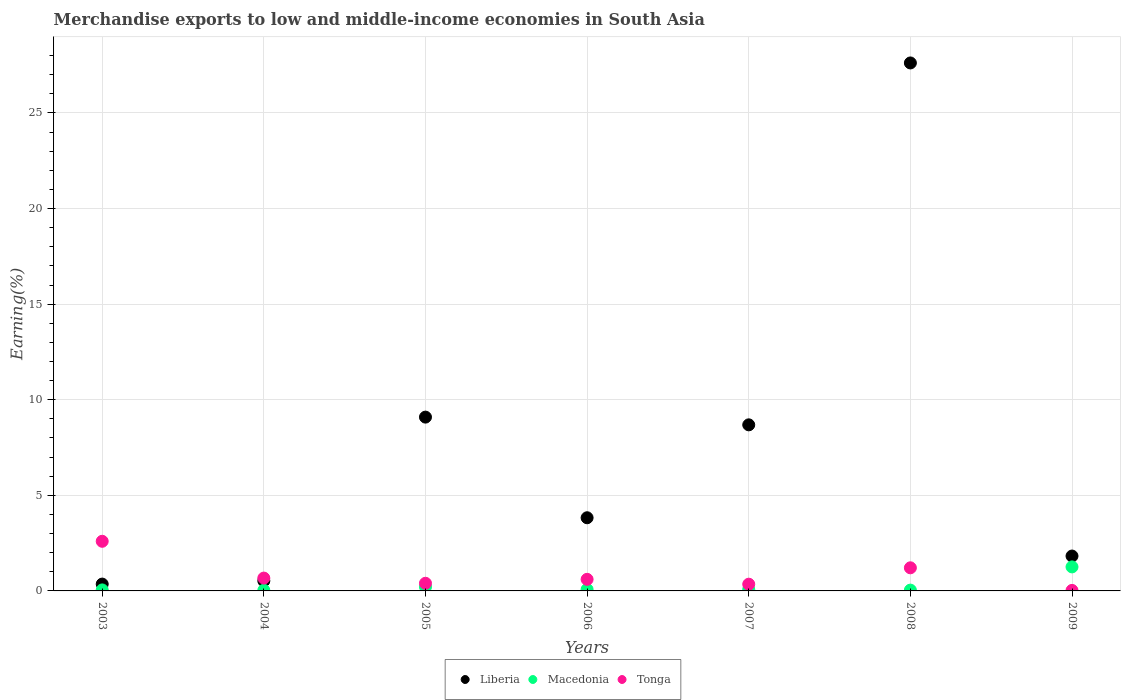What is the percentage of amount earned from merchandise exports in Liberia in 2009?
Your answer should be very brief. 1.82. Across all years, what is the maximum percentage of amount earned from merchandise exports in Liberia?
Make the answer very short. 27.61. Across all years, what is the minimum percentage of amount earned from merchandise exports in Liberia?
Give a very brief answer. 0.36. In which year was the percentage of amount earned from merchandise exports in Macedonia maximum?
Offer a very short reply. 2009. In which year was the percentage of amount earned from merchandise exports in Tonga minimum?
Give a very brief answer. 2009. What is the total percentage of amount earned from merchandise exports in Tonga in the graph?
Your response must be concise. 5.86. What is the difference between the percentage of amount earned from merchandise exports in Liberia in 2003 and that in 2007?
Offer a terse response. -8.33. What is the difference between the percentage of amount earned from merchandise exports in Tonga in 2003 and the percentage of amount earned from merchandise exports in Liberia in 2008?
Offer a terse response. -25.02. What is the average percentage of amount earned from merchandise exports in Liberia per year?
Keep it short and to the point. 7.42. In the year 2004, what is the difference between the percentage of amount earned from merchandise exports in Macedonia and percentage of amount earned from merchandise exports in Tonga?
Give a very brief answer. -0.64. In how many years, is the percentage of amount earned from merchandise exports in Liberia greater than 6 %?
Your response must be concise. 3. What is the ratio of the percentage of amount earned from merchandise exports in Tonga in 2006 to that in 2007?
Your answer should be compact. 1.72. What is the difference between the highest and the second highest percentage of amount earned from merchandise exports in Liberia?
Your answer should be compact. 18.52. What is the difference between the highest and the lowest percentage of amount earned from merchandise exports in Macedonia?
Make the answer very short. 1.22. In how many years, is the percentage of amount earned from merchandise exports in Tonga greater than the average percentage of amount earned from merchandise exports in Tonga taken over all years?
Give a very brief answer. 2. Is it the case that in every year, the sum of the percentage of amount earned from merchandise exports in Tonga and percentage of amount earned from merchandise exports in Macedonia  is greater than the percentage of amount earned from merchandise exports in Liberia?
Provide a short and direct response. No. Does the percentage of amount earned from merchandise exports in Liberia monotonically increase over the years?
Provide a succinct answer. No. Is the percentage of amount earned from merchandise exports in Tonga strictly greater than the percentage of amount earned from merchandise exports in Liberia over the years?
Make the answer very short. No. Is the percentage of amount earned from merchandise exports in Macedonia strictly less than the percentage of amount earned from merchandise exports in Tonga over the years?
Provide a short and direct response. No. How many years are there in the graph?
Offer a very short reply. 7. Are the values on the major ticks of Y-axis written in scientific E-notation?
Your answer should be compact. No. How many legend labels are there?
Your response must be concise. 3. What is the title of the graph?
Provide a succinct answer. Merchandise exports to low and middle-income economies in South Asia. Does "Virgin Islands" appear as one of the legend labels in the graph?
Your answer should be very brief. No. What is the label or title of the Y-axis?
Your answer should be very brief. Earning(%). What is the Earning(%) in Liberia in 2003?
Keep it short and to the point. 0.36. What is the Earning(%) in Macedonia in 2003?
Make the answer very short. 0.05. What is the Earning(%) in Tonga in 2003?
Provide a succinct answer. 2.6. What is the Earning(%) of Liberia in 2004?
Make the answer very short. 0.53. What is the Earning(%) in Macedonia in 2004?
Offer a very short reply. 0.03. What is the Earning(%) of Tonga in 2004?
Make the answer very short. 0.67. What is the Earning(%) of Liberia in 2005?
Your response must be concise. 9.09. What is the Earning(%) of Macedonia in 2005?
Provide a succinct answer. 0.21. What is the Earning(%) of Tonga in 2005?
Ensure brevity in your answer.  0.4. What is the Earning(%) in Liberia in 2006?
Your answer should be very brief. 3.83. What is the Earning(%) in Macedonia in 2006?
Your answer should be compact. 0.08. What is the Earning(%) of Tonga in 2006?
Provide a succinct answer. 0.61. What is the Earning(%) of Liberia in 2007?
Your response must be concise. 8.69. What is the Earning(%) in Macedonia in 2007?
Offer a very short reply. 0.08. What is the Earning(%) in Tonga in 2007?
Keep it short and to the point. 0.35. What is the Earning(%) of Liberia in 2008?
Offer a terse response. 27.61. What is the Earning(%) in Macedonia in 2008?
Offer a terse response. 0.04. What is the Earning(%) in Tonga in 2008?
Provide a succinct answer. 1.21. What is the Earning(%) of Liberia in 2009?
Give a very brief answer. 1.82. What is the Earning(%) in Macedonia in 2009?
Ensure brevity in your answer.  1.26. What is the Earning(%) in Tonga in 2009?
Your answer should be compact. 0.03. Across all years, what is the maximum Earning(%) in Liberia?
Ensure brevity in your answer.  27.61. Across all years, what is the maximum Earning(%) of Macedonia?
Offer a terse response. 1.26. Across all years, what is the maximum Earning(%) of Tonga?
Provide a short and direct response. 2.6. Across all years, what is the minimum Earning(%) of Liberia?
Provide a short and direct response. 0.36. Across all years, what is the minimum Earning(%) in Macedonia?
Make the answer very short. 0.03. Across all years, what is the minimum Earning(%) in Tonga?
Your answer should be very brief. 0.03. What is the total Earning(%) in Liberia in the graph?
Give a very brief answer. 51.93. What is the total Earning(%) of Macedonia in the graph?
Provide a succinct answer. 1.75. What is the total Earning(%) of Tonga in the graph?
Your answer should be very brief. 5.86. What is the difference between the Earning(%) of Liberia in 2003 and that in 2004?
Provide a short and direct response. -0.17. What is the difference between the Earning(%) of Macedonia in 2003 and that in 2004?
Provide a short and direct response. 0.02. What is the difference between the Earning(%) in Tonga in 2003 and that in 2004?
Your answer should be compact. 1.92. What is the difference between the Earning(%) of Liberia in 2003 and that in 2005?
Ensure brevity in your answer.  -8.73. What is the difference between the Earning(%) of Macedonia in 2003 and that in 2005?
Offer a terse response. -0.16. What is the difference between the Earning(%) of Tonga in 2003 and that in 2005?
Offer a very short reply. 2.2. What is the difference between the Earning(%) in Liberia in 2003 and that in 2006?
Your answer should be compact. -3.47. What is the difference between the Earning(%) in Macedonia in 2003 and that in 2006?
Provide a succinct answer. -0.02. What is the difference between the Earning(%) of Tonga in 2003 and that in 2006?
Offer a very short reply. 1.99. What is the difference between the Earning(%) in Liberia in 2003 and that in 2007?
Your answer should be compact. -8.33. What is the difference between the Earning(%) of Macedonia in 2003 and that in 2007?
Provide a short and direct response. -0.03. What is the difference between the Earning(%) of Tonga in 2003 and that in 2007?
Offer a terse response. 2.24. What is the difference between the Earning(%) of Liberia in 2003 and that in 2008?
Make the answer very short. -27.26. What is the difference between the Earning(%) of Macedonia in 2003 and that in 2008?
Make the answer very short. 0.01. What is the difference between the Earning(%) of Tonga in 2003 and that in 2008?
Provide a short and direct response. 1.39. What is the difference between the Earning(%) in Liberia in 2003 and that in 2009?
Keep it short and to the point. -1.47. What is the difference between the Earning(%) in Macedonia in 2003 and that in 2009?
Give a very brief answer. -1.2. What is the difference between the Earning(%) in Tonga in 2003 and that in 2009?
Provide a short and direct response. 2.57. What is the difference between the Earning(%) in Liberia in 2004 and that in 2005?
Offer a very short reply. -8.56. What is the difference between the Earning(%) in Macedonia in 2004 and that in 2005?
Your answer should be very brief. -0.18. What is the difference between the Earning(%) in Tonga in 2004 and that in 2005?
Offer a terse response. 0.27. What is the difference between the Earning(%) of Liberia in 2004 and that in 2006?
Give a very brief answer. -3.3. What is the difference between the Earning(%) of Macedonia in 2004 and that in 2006?
Your response must be concise. -0.04. What is the difference between the Earning(%) in Tonga in 2004 and that in 2006?
Offer a very short reply. 0.07. What is the difference between the Earning(%) in Liberia in 2004 and that in 2007?
Offer a very short reply. -8.16. What is the difference between the Earning(%) of Macedonia in 2004 and that in 2007?
Make the answer very short. -0.05. What is the difference between the Earning(%) in Tonga in 2004 and that in 2007?
Offer a terse response. 0.32. What is the difference between the Earning(%) in Liberia in 2004 and that in 2008?
Make the answer very short. -27.09. What is the difference between the Earning(%) of Macedonia in 2004 and that in 2008?
Ensure brevity in your answer.  -0.01. What is the difference between the Earning(%) in Tonga in 2004 and that in 2008?
Your response must be concise. -0.54. What is the difference between the Earning(%) in Liberia in 2004 and that in 2009?
Your answer should be compact. -1.3. What is the difference between the Earning(%) in Macedonia in 2004 and that in 2009?
Make the answer very short. -1.22. What is the difference between the Earning(%) in Tonga in 2004 and that in 2009?
Provide a short and direct response. 0.64. What is the difference between the Earning(%) of Liberia in 2005 and that in 2006?
Ensure brevity in your answer.  5.26. What is the difference between the Earning(%) of Macedonia in 2005 and that in 2006?
Your answer should be compact. 0.13. What is the difference between the Earning(%) of Tonga in 2005 and that in 2006?
Give a very brief answer. -0.21. What is the difference between the Earning(%) in Liberia in 2005 and that in 2007?
Provide a short and direct response. 0.4. What is the difference between the Earning(%) in Macedonia in 2005 and that in 2007?
Offer a very short reply. 0.13. What is the difference between the Earning(%) of Tonga in 2005 and that in 2007?
Provide a short and direct response. 0.05. What is the difference between the Earning(%) in Liberia in 2005 and that in 2008?
Your answer should be compact. -18.52. What is the difference between the Earning(%) of Macedonia in 2005 and that in 2008?
Your answer should be compact. 0.17. What is the difference between the Earning(%) of Tonga in 2005 and that in 2008?
Your answer should be very brief. -0.81. What is the difference between the Earning(%) in Liberia in 2005 and that in 2009?
Ensure brevity in your answer.  7.27. What is the difference between the Earning(%) of Macedonia in 2005 and that in 2009?
Keep it short and to the point. -1.05. What is the difference between the Earning(%) of Tonga in 2005 and that in 2009?
Make the answer very short. 0.37. What is the difference between the Earning(%) of Liberia in 2006 and that in 2007?
Ensure brevity in your answer.  -4.86. What is the difference between the Earning(%) in Macedonia in 2006 and that in 2007?
Offer a terse response. -0. What is the difference between the Earning(%) in Tonga in 2006 and that in 2007?
Make the answer very short. 0.25. What is the difference between the Earning(%) of Liberia in 2006 and that in 2008?
Provide a short and direct response. -23.79. What is the difference between the Earning(%) in Macedonia in 2006 and that in 2008?
Keep it short and to the point. 0.03. What is the difference between the Earning(%) in Tonga in 2006 and that in 2008?
Your answer should be very brief. -0.6. What is the difference between the Earning(%) in Liberia in 2006 and that in 2009?
Keep it short and to the point. 2. What is the difference between the Earning(%) in Macedonia in 2006 and that in 2009?
Keep it short and to the point. -1.18. What is the difference between the Earning(%) of Tonga in 2006 and that in 2009?
Ensure brevity in your answer.  0.58. What is the difference between the Earning(%) in Liberia in 2007 and that in 2008?
Your answer should be very brief. -18.93. What is the difference between the Earning(%) of Macedonia in 2007 and that in 2008?
Your response must be concise. 0.04. What is the difference between the Earning(%) in Tonga in 2007 and that in 2008?
Ensure brevity in your answer.  -0.86. What is the difference between the Earning(%) in Liberia in 2007 and that in 2009?
Your answer should be very brief. 6.86. What is the difference between the Earning(%) of Macedonia in 2007 and that in 2009?
Provide a short and direct response. -1.18. What is the difference between the Earning(%) in Tonga in 2007 and that in 2009?
Provide a succinct answer. 0.32. What is the difference between the Earning(%) of Liberia in 2008 and that in 2009?
Offer a terse response. 25.79. What is the difference between the Earning(%) in Macedonia in 2008 and that in 2009?
Ensure brevity in your answer.  -1.21. What is the difference between the Earning(%) of Tonga in 2008 and that in 2009?
Offer a very short reply. 1.18. What is the difference between the Earning(%) of Liberia in 2003 and the Earning(%) of Macedonia in 2004?
Offer a terse response. 0.32. What is the difference between the Earning(%) of Liberia in 2003 and the Earning(%) of Tonga in 2004?
Keep it short and to the point. -0.31. What is the difference between the Earning(%) in Macedonia in 2003 and the Earning(%) in Tonga in 2004?
Offer a terse response. -0.62. What is the difference between the Earning(%) of Liberia in 2003 and the Earning(%) of Macedonia in 2005?
Ensure brevity in your answer.  0.15. What is the difference between the Earning(%) of Liberia in 2003 and the Earning(%) of Tonga in 2005?
Keep it short and to the point. -0.04. What is the difference between the Earning(%) of Macedonia in 2003 and the Earning(%) of Tonga in 2005?
Offer a terse response. -0.35. What is the difference between the Earning(%) of Liberia in 2003 and the Earning(%) of Macedonia in 2006?
Provide a succinct answer. 0.28. What is the difference between the Earning(%) of Liberia in 2003 and the Earning(%) of Tonga in 2006?
Provide a short and direct response. -0.25. What is the difference between the Earning(%) in Macedonia in 2003 and the Earning(%) in Tonga in 2006?
Keep it short and to the point. -0.55. What is the difference between the Earning(%) of Liberia in 2003 and the Earning(%) of Macedonia in 2007?
Provide a short and direct response. 0.28. What is the difference between the Earning(%) of Liberia in 2003 and the Earning(%) of Tonga in 2007?
Provide a short and direct response. 0.01. What is the difference between the Earning(%) in Macedonia in 2003 and the Earning(%) in Tonga in 2007?
Provide a succinct answer. -0.3. What is the difference between the Earning(%) of Liberia in 2003 and the Earning(%) of Macedonia in 2008?
Provide a succinct answer. 0.32. What is the difference between the Earning(%) of Liberia in 2003 and the Earning(%) of Tonga in 2008?
Ensure brevity in your answer.  -0.85. What is the difference between the Earning(%) in Macedonia in 2003 and the Earning(%) in Tonga in 2008?
Your response must be concise. -1.16. What is the difference between the Earning(%) of Liberia in 2003 and the Earning(%) of Macedonia in 2009?
Ensure brevity in your answer.  -0.9. What is the difference between the Earning(%) of Liberia in 2003 and the Earning(%) of Tonga in 2009?
Give a very brief answer. 0.33. What is the difference between the Earning(%) of Macedonia in 2003 and the Earning(%) of Tonga in 2009?
Provide a succinct answer. 0.03. What is the difference between the Earning(%) in Liberia in 2004 and the Earning(%) in Macedonia in 2005?
Ensure brevity in your answer.  0.32. What is the difference between the Earning(%) in Liberia in 2004 and the Earning(%) in Tonga in 2005?
Your answer should be very brief. 0.13. What is the difference between the Earning(%) of Macedonia in 2004 and the Earning(%) of Tonga in 2005?
Provide a succinct answer. -0.37. What is the difference between the Earning(%) of Liberia in 2004 and the Earning(%) of Macedonia in 2006?
Give a very brief answer. 0.45. What is the difference between the Earning(%) of Liberia in 2004 and the Earning(%) of Tonga in 2006?
Offer a terse response. -0.08. What is the difference between the Earning(%) in Macedonia in 2004 and the Earning(%) in Tonga in 2006?
Keep it short and to the point. -0.57. What is the difference between the Earning(%) in Liberia in 2004 and the Earning(%) in Macedonia in 2007?
Make the answer very short. 0.45. What is the difference between the Earning(%) of Liberia in 2004 and the Earning(%) of Tonga in 2007?
Give a very brief answer. 0.17. What is the difference between the Earning(%) of Macedonia in 2004 and the Earning(%) of Tonga in 2007?
Keep it short and to the point. -0.32. What is the difference between the Earning(%) in Liberia in 2004 and the Earning(%) in Macedonia in 2008?
Your answer should be compact. 0.48. What is the difference between the Earning(%) in Liberia in 2004 and the Earning(%) in Tonga in 2008?
Make the answer very short. -0.68. What is the difference between the Earning(%) of Macedonia in 2004 and the Earning(%) of Tonga in 2008?
Ensure brevity in your answer.  -1.18. What is the difference between the Earning(%) of Liberia in 2004 and the Earning(%) of Macedonia in 2009?
Keep it short and to the point. -0.73. What is the difference between the Earning(%) in Liberia in 2004 and the Earning(%) in Tonga in 2009?
Your answer should be compact. 0.5. What is the difference between the Earning(%) of Macedonia in 2004 and the Earning(%) of Tonga in 2009?
Provide a short and direct response. 0.01. What is the difference between the Earning(%) of Liberia in 2005 and the Earning(%) of Macedonia in 2006?
Make the answer very short. 9.01. What is the difference between the Earning(%) of Liberia in 2005 and the Earning(%) of Tonga in 2006?
Give a very brief answer. 8.48. What is the difference between the Earning(%) in Macedonia in 2005 and the Earning(%) in Tonga in 2006?
Offer a terse response. -0.4. What is the difference between the Earning(%) in Liberia in 2005 and the Earning(%) in Macedonia in 2007?
Offer a very short reply. 9.01. What is the difference between the Earning(%) in Liberia in 2005 and the Earning(%) in Tonga in 2007?
Your response must be concise. 8.74. What is the difference between the Earning(%) in Macedonia in 2005 and the Earning(%) in Tonga in 2007?
Make the answer very short. -0.14. What is the difference between the Earning(%) in Liberia in 2005 and the Earning(%) in Macedonia in 2008?
Give a very brief answer. 9.05. What is the difference between the Earning(%) of Liberia in 2005 and the Earning(%) of Tonga in 2008?
Your response must be concise. 7.88. What is the difference between the Earning(%) in Macedonia in 2005 and the Earning(%) in Tonga in 2008?
Offer a terse response. -1. What is the difference between the Earning(%) in Liberia in 2005 and the Earning(%) in Macedonia in 2009?
Offer a terse response. 7.83. What is the difference between the Earning(%) of Liberia in 2005 and the Earning(%) of Tonga in 2009?
Keep it short and to the point. 9.06. What is the difference between the Earning(%) of Macedonia in 2005 and the Earning(%) of Tonga in 2009?
Keep it short and to the point. 0.18. What is the difference between the Earning(%) in Liberia in 2006 and the Earning(%) in Macedonia in 2007?
Give a very brief answer. 3.75. What is the difference between the Earning(%) in Liberia in 2006 and the Earning(%) in Tonga in 2007?
Your answer should be compact. 3.48. What is the difference between the Earning(%) of Macedonia in 2006 and the Earning(%) of Tonga in 2007?
Your answer should be very brief. -0.27. What is the difference between the Earning(%) in Liberia in 2006 and the Earning(%) in Macedonia in 2008?
Provide a short and direct response. 3.78. What is the difference between the Earning(%) in Liberia in 2006 and the Earning(%) in Tonga in 2008?
Provide a succinct answer. 2.62. What is the difference between the Earning(%) in Macedonia in 2006 and the Earning(%) in Tonga in 2008?
Offer a very short reply. -1.13. What is the difference between the Earning(%) of Liberia in 2006 and the Earning(%) of Macedonia in 2009?
Your response must be concise. 2.57. What is the difference between the Earning(%) in Liberia in 2006 and the Earning(%) in Tonga in 2009?
Ensure brevity in your answer.  3.8. What is the difference between the Earning(%) in Macedonia in 2006 and the Earning(%) in Tonga in 2009?
Your answer should be very brief. 0.05. What is the difference between the Earning(%) in Liberia in 2007 and the Earning(%) in Macedonia in 2008?
Ensure brevity in your answer.  8.64. What is the difference between the Earning(%) in Liberia in 2007 and the Earning(%) in Tonga in 2008?
Offer a terse response. 7.48. What is the difference between the Earning(%) in Macedonia in 2007 and the Earning(%) in Tonga in 2008?
Make the answer very short. -1.13. What is the difference between the Earning(%) in Liberia in 2007 and the Earning(%) in Macedonia in 2009?
Your answer should be compact. 7.43. What is the difference between the Earning(%) of Liberia in 2007 and the Earning(%) of Tonga in 2009?
Offer a terse response. 8.66. What is the difference between the Earning(%) of Macedonia in 2007 and the Earning(%) of Tonga in 2009?
Your answer should be very brief. 0.05. What is the difference between the Earning(%) in Liberia in 2008 and the Earning(%) in Macedonia in 2009?
Make the answer very short. 26.36. What is the difference between the Earning(%) in Liberia in 2008 and the Earning(%) in Tonga in 2009?
Make the answer very short. 27.59. What is the difference between the Earning(%) of Macedonia in 2008 and the Earning(%) of Tonga in 2009?
Offer a very short reply. 0.02. What is the average Earning(%) in Liberia per year?
Your answer should be compact. 7.42. What is the average Earning(%) of Macedonia per year?
Provide a short and direct response. 0.25. What is the average Earning(%) of Tonga per year?
Offer a very short reply. 0.84. In the year 2003, what is the difference between the Earning(%) in Liberia and Earning(%) in Macedonia?
Ensure brevity in your answer.  0.3. In the year 2003, what is the difference between the Earning(%) in Liberia and Earning(%) in Tonga?
Offer a very short reply. -2.24. In the year 2003, what is the difference between the Earning(%) in Macedonia and Earning(%) in Tonga?
Offer a very short reply. -2.54. In the year 2004, what is the difference between the Earning(%) of Liberia and Earning(%) of Macedonia?
Your answer should be compact. 0.49. In the year 2004, what is the difference between the Earning(%) in Liberia and Earning(%) in Tonga?
Your answer should be very brief. -0.15. In the year 2004, what is the difference between the Earning(%) of Macedonia and Earning(%) of Tonga?
Offer a terse response. -0.64. In the year 2005, what is the difference between the Earning(%) in Liberia and Earning(%) in Macedonia?
Ensure brevity in your answer.  8.88. In the year 2005, what is the difference between the Earning(%) in Liberia and Earning(%) in Tonga?
Give a very brief answer. 8.69. In the year 2005, what is the difference between the Earning(%) in Macedonia and Earning(%) in Tonga?
Your response must be concise. -0.19. In the year 2006, what is the difference between the Earning(%) in Liberia and Earning(%) in Macedonia?
Your answer should be compact. 3.75. In the year 2006, what is the difference between the Earning(%) of Liberia and Earning(%) of Tonga?
Offer a terse response. 3.22. In the year 2006, what is the difference between the Earning(%) in Macedonia and Earning(%) in Tonga?
Your answer should be very brief. -0.53. In the year 2007, what is the difference between the Earning(%) in Liberia and Earning(%) in Macedonia?
Your answer should be very brief. 8.61. In the year 2007, what is the difference between the Earning(%) in Liberia and Earning(%) in Tonga?
Make the answer very short. 8.33. In the year 2007, what is the difference between the Earning(%) of Macedonia and Earning(%) of Tonga?
Your response must be concise. -0.27. In the year 2008, what is the difference between the Earning(%) of Liberia and Earning(%) of Macedonia?
Give a very brief answer. 27.57. In the year 2008, what is the difference between the Earning(%) in Liberia and Earning(%) in Tonga?
Keep it short and to the point. 26.41. In the year 2008, what is the difference between the Earning(%) in Macedonia and Earning(%) in Tonga?
Provide a short and direct response. -1.17. In the year 2009, what is the difference between the Earning(%) of Liberia and Earning(%) of Macedonia?
Offer a terse response. 0.57. In the year 2009, what is the difference between the Earning(%) in Liberia and Earning(%) in Tonga?
Offer a very short reply. 1.8. In the year 2009, what is the difference between the Earning(%) of Macedonia and Earning(%) of Tonga?
Provide a succinct answer. 1.23. What is the ratio of the Earning(%) of Liberia in 2003 to that in 2004?
Offer a terse response. 0.68. What is the ratio of the Earning(%) of Macedonia in 2003 to that in 2004?
Provide a short and direct response. 1.58. What is the ratio of the Earning(%) of Tonga in 2003 to that in 2004?
Your answer should be compact. 3.86. What is the ratio of the Earning(%) of Liberia in 2003 to that in 2005?
Give a very brief answer. 0.04. What is the ratio of the Earning(%) in Macedonia in 2003 to that in 2005?
Your answer should be compact. 0.25. What is the ratio of the Earning(%) in Tonga in 2003 to that in 2005?
Make the answer very short. 6.49. What is the ratio of the Earning(%) of Liberia in 2003 to that in 2006?
Offer a terse response. 0.09. What is the ratio of the Earning(%) in Macedonia in 2003 to that in 2006?
Offer a very short reply. 0.69. What is the ratio of the Earning(%) in Tonga in 2003 to that in 2006?
Offer a very short reply. 4.28. What is the ratio of the Earning(%) of Liberia in 2003 to that in 2007?
Your response must be concise. 0.04. What is the ratio of the Earning(%) in Macedonia in 2003 to that in 2007?
Keep it short and to the point. 0.67. What is the ratio of the Earning(%) in Tonga in 2003 to that in 2007?
Provide a short and direct response. 7.38. What is the ratio of the Earning(%) in Liberia in 2003 to that in 2008?
Keep it short and to the point. 0.01. What is the ratio of the Earning(%) of Macedonia in 2003 to that in 2008?
Your answer should be compact. 1.25. What is the ratio of the Earning(%) in Tonga in 2003 to that in 2008?
Offer a very short reply. 2.15. What is the ratio of the Earning(%) of Liberia in 2003 to that in 2009?
Your answer should be compact. 0.2. What is the ratio of the Earning(%) of Macedonia in 2003 to that in 2009?
Your answer should be compact. 0.04. What is the ratio of the Earning(%) of Tonga in 2003 to that in 2009?
Your answer should be compact. 96.5. What is the ratio of the Earning(%) of Liberia in 2004 to that in 2005?
Give a very brief answer. 0.06. What is the ratio of the Earning(%) of Macedonia in 2004 to that in 2005?
Provide a succinct answer. 0.16. What is the ratio of the Earning(%) in Tonga in 2004 to that in 2005?
Keep it short and to the point. 1.68. What is the ratio of the Earning(%) of Liberia in 2004 to that in 2006?
Offer a terse response. 0.14. What is the ratio of the Earning(%) of Macedonia in 2004 to that in 2006?
Keep it short and to the point. 0.44. What is the ratio of the Earning(%) of Tonga in 2004 to that in 2006?
Keep it short and to the point. 1.11. What is the ratio of the Earning(%) of Liberia in 2004 to that in 2007?
Offer a very short reply. 0.06. What is the ratio of the Earning(%) in Macedonia in 2004 to that in 2007?
Your answer should be very brief. 0.42. What is the ratio of the Earning(%) in Tonga in 2004 to that in 2007?
Offer a terse response. 1.91. What is the ratio of the Earning(%) in Liberia in 2004 to that in 2008?
Your answer should be very brief. 0.02. What is the ratio of the Earning(%) of Macedonia in 2004 to that in 2008?
Your answer should be very brief. 0.79. What is the ratio of the Earning(%) of Tonga in 2004 to that in 2008?
Offer a very short reply. 0.56. What is the ratio of the Earning(%) in Liberia in 2004 to that in 2009?
Your answer should be compact. 0.29. What is the ratio of the Earning(%) in Macedonia in 2004 to that in 2009?
Ensure brevity in your answer.  0.03. What is the ratio of the Earning(%) of Tonga in 2004 to that in 2009?
Your response must be concise. 24.97. What is the ratio of the Earning(%) in Liberia in 2005 to that in 2006?
Give a very brief answer. 2.38. What is the ratio of the Earning(%) in Macedonia in 2005 to that in 2006?
Ensure brevity in your answer.  2.75. What is the ratio of the Earning(%) of Tonga in 2005 to that in 2006?
Give a very brief answer. 0.66. What is the ratio of the Earning(%) of Liberia in 2005 to that in 2007?
Provide a short and direct response. 1.05. What is the ratio of the Earning(%) in Macedonia in 2005 to that in 2007?
Offer a terse response. 2.65. What is the ratio of the Earning(%) in Tonga in 2005 to that in 2007?
Give a very brief answer. 1.14. What is the ratio of the Earning(%) in Liberia in 2005 to that in 2008?
Your answer should be very brief. 0.33. What is the ratio of the Earning(%) of Macedonia in 2005 to that in 2008?
Provide a short and direct response. 4.98. What is the ratio of the Earning(%) of Tonga in 2005 to that in 2008?
Your answer should be compact. 0.33. What is the ratio of the Earning(%) in Liberia in 2005 to that in 2009?
Offer a very short reply. 4.98. What is the ratio of the Earning(%) of Macedonia in 2005 to that in 2009?
Keep it short and to the point. 0.17. What is the ratio of the Earning(%) of Tonga in 2005 to that in 2009?
Provide a succinct answer. 14.87. What is the ratio of the Earning(%) of Liberia in 2006 to that in 2007?
Provide a short and direct response. 0.44. What is the ratio of the Earning(%) in Macedonia in 2006 to that in 2007?
Keep it short and to the point. 0.97. What is the ratio of the Earning(%) of Tonga in 2006 to that in 2007?
Ensure brevity in your answer.  1.72. What is the ratio of the Earning(%) of Liberia in 2006 to that in 2008?
Provide a succinct answer. 0.14. What is the ratio of the Earning(%) of Macedonia in 2006 to that in 2008?
Your answer should be very brief. 1.81. What is the ratio of the Earning(%) of Tonga in 2006 to that in 2008?
Your answer should be very brief. 0.5. What is the ratio of the Earning(%) in Liberia in 2006 to that in 2009?
Offer a terse response. 2.1. What is the ratio of the Earning(%) of Macedonia in 2006 to that in 2009?
Your answer should be compact. 0.06. What is the ratio of the Earning(%) in Tonga in 2006 to that in 2009?
Keep it short and to the point. 22.52. What is the ratio of the Earning(%) of Liberia in 2007 to that in 2008?
Make the answer very short. 0.31. What is the ratio of the Earning(%) in Macedonia in 2007 to that in 2008?
Ensure brevity in your answer.  1.88. What is the ratio of the Earning(%) of Tonga in 2007 to that in 2008?
Your answer should be compact. 0.29. What is the ratio of the Earning(%) in Liberia in 2007 to that in 2009?
Provide a succinct answer. 4.76. What is the ratio of the Earning(%) in Macedonia in 2007 to that in 2009?
Give a very brief answer. 0.06. What is the ratio of the Earning(%) of Tonga in 2007 to that in 2009?
Keep it short and to the point. 13.07. What is the ratio of the Earning(%) of Liberia in 2008 to that in 2009?
Offer a very short reply. 15.14. What is the ratio of the Earning(%) in Macedonia in 2008 to that in 2009?
Give a very brief answer. 0.03. What is the ratio of the Earning(%) of Tonga in 2008 to that in 2009?
Offer a very short reply. 44.94. What is the difference between the highest and the second highest Earning(%) in Liberia?
Your response must be concise. 18.52. What is the difference between the highest and the second highest Earning(%) in Macedonia?
Ensure brevity in your answer.  1.05. What is the difference between the highest and the second highest Earning(%) of Tonga?
Keep it short and to the point. 1.39. What is the difference between the highest and the lowest Earning(%) of Liberia?
Keep it short and to the point. 27.26. What is the difference between the highest and the lowest Earning(%) of Macedonia?
Your response must be concise. 1.22. What is the difference between the highest and the lowest Earning(%) of Tonga?
Make the answer very short. 2.57. 